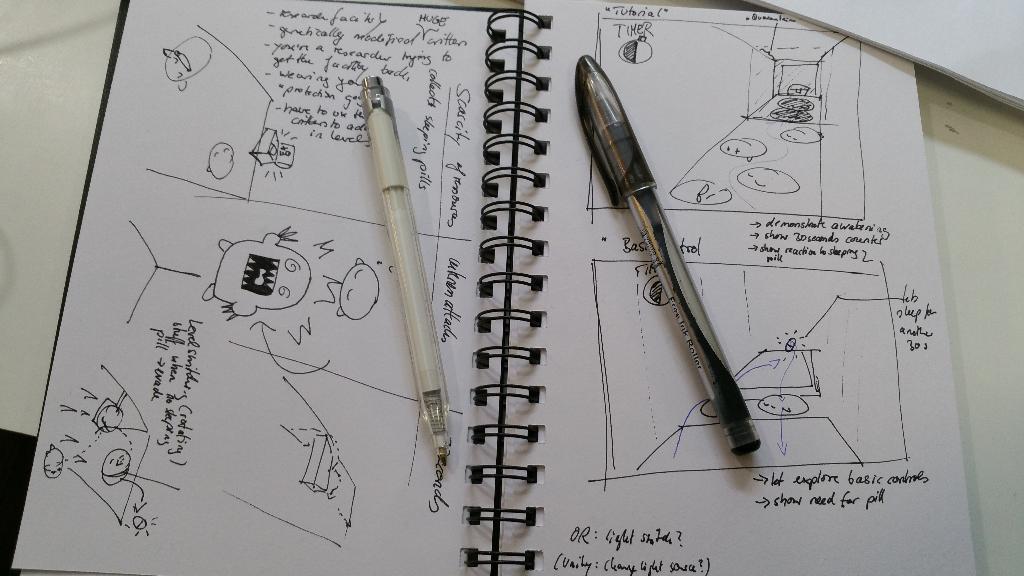How would you summarize this image in a sentence or two? On a white surface we can see a spiral book and there is something written. We can see some drawing. We can see two pens are placed on the book. We can see white papers. 